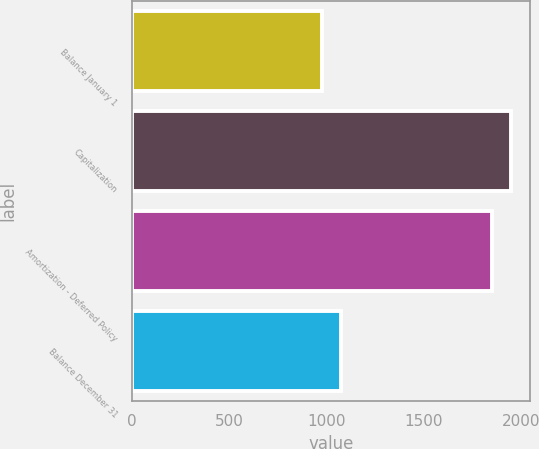Convert chart. <chart><loc_0><loc_0><loc_500><loc_500><bar_chart><fcel>Balance January 1<fcel>Capitalization<fcel>Amortization - Deferred Policy<fcel>Balance December 31<nl><fcel>975<fcel>1947.1<fcel>1850<fcel>1072.1<nl></chart> 